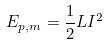Convert formula to latex. <formula><loc_0><loc_0><loc_500><loc_500>E _ { p , m } = \frac { 1 } { 2 } L I ^ { 2 }</formula> 